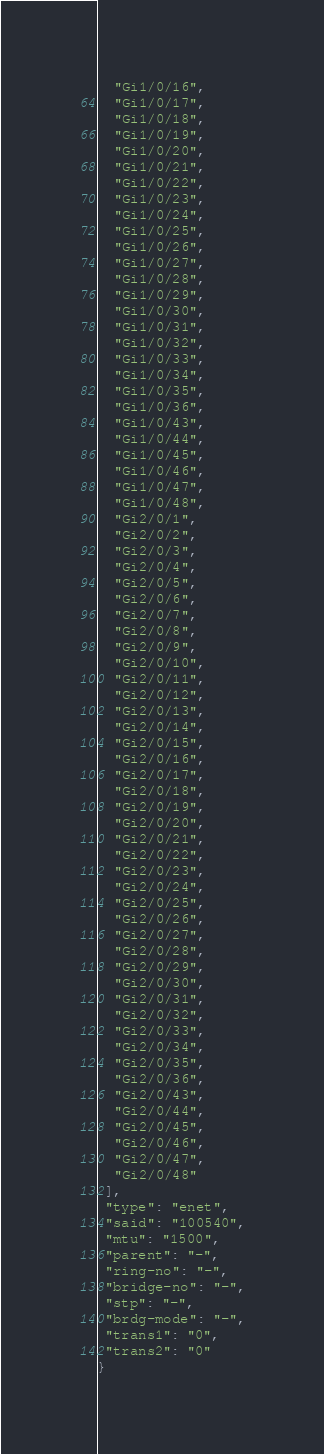<code> <loc_0><loc_0><loc_500><loc_500><_Python_>  "Gi1/0/16",
  "Gi1/0/17",
  "Gi1/0/18",
  "Gi1/0/19",
  "Gi1/0/20",
  "Gi1/0/21",
  "Gi1/0/22",
  "Gi1/0/23",
  "Gi1/0/24",
  "Gi1/0/25",
  "Gi1/0/26",
  "Gi1/0/27",
  "Gi1/0/28",
  "Gi1/0/29",
  "Gi1/0/30",
  "Gi1/0/31",
  "Gi1/0/32",
  "Gi1/0/33",
  "Gi1/0/34",
  "Gi1/0/35",
  "Gi1/0/36",
  "Gi1/0/43",
  "Gi1/0/44",
  "Gi1/0/45",
  "Gi1/0/46",
  "Gi1/0/47",
  "Gi1/0/48",
  "Gi2/0/1",
  "Gi2/0/2",
  "Gi2/0/3",
  "Gi2/0/4",
  "Gi2/0/5",
  "Gi2/0/6",
  "Gi2/0/7",
  "Gi2/0/8",
  "Gi2/0/9",
  "Gi2/0/10",
  "Gi2/0/11",
  "Gi2/0/12",
  "Gi2/0/13",
  "Gi2/0/14",
  "Gi2/0/15",
  "Gi2/0/16",
  "Gi2/0/17",
  "Gi2/0/18",
  "Gi2/0/19",
  "Gi2/0/20",
  "Gi2/0/21",
  "Gi2/0/22",
  "Gi2/0/23",
  "Gi2/0/24",
  "Gi2/0/25",
  "Gi2/0/26",
  "Gi2/0/27",
  "Gi2/0/28",
  "Gi2/0/29",
  "Gi2/0/30",
  "Gi2/0/31",
  "Gi2/0/32",
  "Gi2/0/33",
  "Gi2/0/34",
  "Gi2/0/35",
  "Gi2/0/36",
  "Gi2/0/43",
  "Gi2/0/44",
  "Gi2/0/45",
  "Gi2/0/46",
  "Gi2/0/47",
  "Gi2/0/48"
 ],
 "type": "enet",
 "said": "100540",
 "mtu": "1500",
 "parent": "-",
 "ring-no": "-",
 "bridge-no": "-",
 "stp": "-",
 "brdg-mode": "-",
 "trans1": "0",
 "trans2": "0"
}</code> 